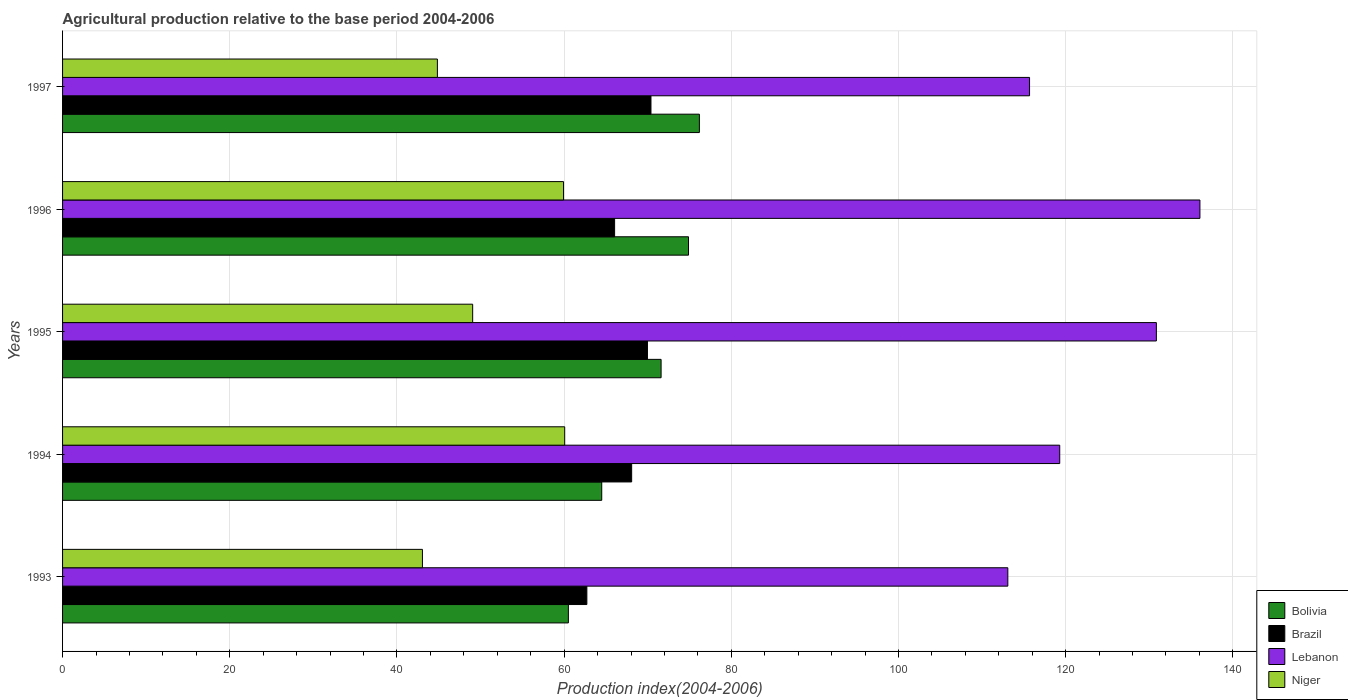How many groups of bars are there?
Your answer should be very brief. 5. How many bars are there on the 3rd tick from the bottom?
Your answer should be compact. 4. What is the agricultural production index in Lebanon in 1996?
Ensure brevity in your answer.  136.06. Across all years, what is the maximum agricultural production index in Bolivia?
Your answer should be very brief. 76.18. Across all years, what is the minimum agricultural production index in Lebanon?
Your response must be concise. 113.08. In which year was the agricultural production index in Niger maximum?
Your response must be concise. 1994. In which year was the agricultural production index in Bolivia minimum?
Keep it short and to the point. 1993. What is the total agricultural production index in Lebanon in the graph?
Make the answer very short. 614.96. What is the difference between the agricultural production index in Niger in 1995 and that in 1997?
Provide a succinct answer. 4.22. What is the difference between the agricultural production index in Lebanon in 1994 and the agricultural production index in Brazil in 1997?
Keep it short and to the point. 48.9. What is the average agricultural production index in Lebanon per year?
Your response must be concise. 122.99. In the year 1996, what is the difference between the agricultural production index in Lebanon and agricultural production index in Niger?
Your answer should be very brief. 76.13. In how many years, is the agricultural production index in Lebanon greater than 76 ?
Keep it short and to the point. 5. What is the ratio of the agricultural production index in Lebanon in 1996 to that in 1997?
Your response must be concise. 1.18. What is the difference between the highest and the second highest agricultural production index in Lebanon?
Make the answer very short. 5.21. What is the difference between the highest and the lowest agricultural production index in Lebanon?
Your answer should be very brief. 22.98. Is the sum of the agricultural production index in Brazil in 1994 and 1995 greater than the maximum agricultural production index in Niger across all years?
Your response must be concise. Yes. What does the 4th bar from the top in 1995 represents?
Make the answer very short. Bolivia. What does the 3rd bar from the bottom in 1994 represents?
Ensure brevity in your answer.  Lebanon. Is it the case that in every year, the sum of the agricultural production index in Lebanon and agricultural production index in Bolivia is greater than the agricultural production index in Brazil?
Provide a succinct answer. Yes. How many bars are there?
Provide a succinct answer. 20. Are all the bars in the graph horizontal?
Your answer should be compact. Yes. How many years are there in the graph?
Provide a short and direct response. 5. What is the difference between two consecutive major ticks on the X-axis?
Your answer should be very brief. 20. Does the graph contain any zero values?
Keep it short and to the point. No. Does the graph contain grids?
Keep it short and to the point. Yes. Where does the legend appear in the graph?
Provide a short and direct response. Bottom right. How many legend labels are there?
Give a very brief answer. 4. How are the legend labels stacked?
Your response must be concise. Vertical. What is the title of the graph?
Provide a succinct answer. Agricultural production relative to the base period 2004-2006. Does "Samoa" appear as one of the legend labels in the graph?
Provide a short and direct response. No. What is the label or title of the X-axis?
Your answer should be very brief. Production index(2004-2006). What is the Production index(2004-2006) of Bolivia in 1993?
Make the answer very short. 60.51. What is the Production index(2004-2006) in Brazil in 1993?
Provide a short and direct response. 62.72. What is the Production index(2004-2006) in Lebanon in 1993?
Provide a short and direct response. 113.08. What is the Production index(2004-2006) of Niger in 1993?
Offer a terse response. 43.05. What is the Production index(2004-2006) in Bolivia in 1994?
Provide a succinct answer. 64.5. What is the Production index(2004-2006) of Brazil in 1994?
Offer a very short reply. 68.08. What is the Production index(2004-2006) in Lebanon in 1994?
Offer a terse response. 119.29. What is the Production index(2004-2006) of Niger in 1994?
Provide a succinct answer. 60.07. What is the Production index(2004-2006) in Bolivia in 1995?
Ensure brevity in your answer.  71.6. What is the Production index(2004-2006) in Brazil in 1995?
Make the answer very short. 69.97. What is the Production index(2004-2006) in Lebanon in 1995?
Make the answer very short. 130.85. What is the Production index(2004-2006) in Niger in 1995?
Provide a succinct answer. 49.06. What is the Production index(2004-2006) in Bolivia in 1996?
Offer a very short reply. 74.88. What is the Production index(2004-2006) in Brazil in 1996?
Offer a terse response. 66.04. What is the Production index(2004-2006) of Lebanon in 1996?
Provide a short and direct response. 136.06. What is the Production index(2004-2006) in Niger in 1996?
Offer a terse response. 59.93. What is the Production index(2004-2006) in Bolivia in 1997?
Offer a very short reply. 76.18. What is the Production index(2004-2006) of Brazil in 1997?
Your answer should be very brief. 70.39. What is the Production index(2004-2006) in Lebanon in 1997?
Provide a short and direct response. 115.68. What is the Production index(2004-2006) of Niger in 1997?
Provide a succinct answer. 44.84. Across all years, what is the maximum Production index(2004-2006) in Bolivia?
Provide a succinct answer. 76.18. Across all years, what is the maximum Production index(2004-2006) of Brazil?
Your answer should be very brief. 70.39. Across all years, what is the maximum Production index(2004-2006) of Lebanon?
Make the answer very short. 136.06. Across all years, what is the maximum Production index(2004-2006) in Niger?
Your answer should be compact. 60.07. Across all years, what is the minimum Production index(2004-2006) in Bolivia?
Keep it short and to the point. 60.51. Across all years, what is the minimum Production index(2004-2006) in Brazil?
Your answer should be compact. 62.72. Across all years, what is the minimum Production index(2004-2006) of Lebanon?
Your response must be concise. 113.08. Across all years, what is the minimum Production index(2004-2006) of Niger?
Give a very brief answer. 43.05. What is the total Production index(2004-2006) in Bolivia in the graph?
Your answer should be compact. 347.67. What is the total Production index(2004-2006) in Brazil in the graph?
Your answer should be very brief. 337.2. What is the total Production index(2004-2006) in Lebanon in the graph?
Your answer should be very brief. 614.96. What is the total Production index(2004-2006) in Niger in the graph?
Your response must be concise. 256.95. What is the difference between the Production index(2004-2006) in Bolivia in 1993 and that in 1994?
Provide a succinct answer. -3.99. What is the difference between the Production index(2004-2006) of Brazil in 1993 and that in 1994?
Ensure brevity in your answer.  -5.36. What is the difference between the Production index(2004-2006) in Lebanon in 1993 and that in 1994?
Give a very brief answer. -6.21. What is the difference between the Production index(2004-2006) in Niger in 1993 and that in 1994?
Give a very brief answer. -17.02. What is the difference between the Production index(2004-2006) in Bolivia in 1993 and that in 1995?
Your answer should be compact. -11.09. What is the difference between the Production index(2004-2006) in Brazil in 1993 and that in 1995?
Make the answer very short. -7.25. What is the difference between the Production index(2004-2006) in Lebanon in 1993 and that in 1995?
Your response must be concise. -17.77. What is the difference between the Production index(2004-2006) of Niger in 1993 and that in 1995?
Keep it short and to the point. -6.01. What is the difference between the Production index(2004-2006) of Bolivia in 1993 and that in 1996?
Your answer should be very brief. -14.37. What is the difference between the Production index(2004-2006) of Brazil in 1993 and that in 1996?
Your answer should be very brief. -3.32. What is the difference between the Production index(2004-2006) in Lebanon in 1993 and that in 1996?
Keep it short and to the point. -22.98. What is the difference between the Production index(2004-2006) in Niger in 1993 and that in 1996?
Offer a very short reply. -16.88. What is the difference between the Production index(2004-2006) in Bolivia in 1993 and that in 1997?
Provide a succinct answer. -15.67. What is the difference between the Production index(2004-2006) in Brazil in 1993 and that in 1997?
Offer a terse response. -7.67. What is the difference between the Production index(2004-2006) of Niger in 1993 and that in 1997?
Your answer should be very brief. -1.79. What is the difference between the Production index(2004-2006) of Bolivia in 1994 and that in 1995?
Keep it short and to the point. -7.1. What is the difference between the Production index(2004-2006) in Brazil in 1994 and that in 1995?
Your answer should be very brief. -1.89. What is the difference between the Production index(2004-2006) of Lebanon in 1994 and that in 1995?
Your answer should be compact. -11.56. What is the difference between the Production index(2004-2006) in Niger in 1994 and that in 1995?
Ensure brevity in your answer.  11.01. What is the difference between the Production index(2004-2006) of Bolivia in 1994 and that in 1996?
Your response must be concise. -10.38. What is the difference between the Production index(2004-2006) of Brazil in 1994 and that in 1996?
Your answer should be very brief. 2.04. What is the difference between the Production index(2004-2006) of Lebanon in 1994 and that in 1996?
Make the answer very short. -16.77. What is the difference between the Production index(2004-2006) of Niger in 1994 and that in 1996?
Ensure brevity in your answer.  0.14. What is the difference between the Production index(2004-2006) of Bolivia in 1994 and that in 1997?
Offer a terse response. -11.68. What is the difference between the Production index(2004-2006) of Brazil in 1994 and that in 1997?
Provide a succinct answer. -2.31. What is the difference between the Production index(2004-2006) of Lebanon in 1994 and that in 1997?
Give a very brief answer. 3.61. What is the difference between the Production index(2004-2006) in Niger in 1994 and that in 1997?
Ensure brevity in your answer.  15.23. What is the difference between the Production index(2004-2006) of Bolivia in 1995 and that in 1996?
Offer a terse response. -3.28. What is the difference between the Production index(2004-2006) of Brazil in 1995 and that in 1996?
Your answer should be very brief. 3.93. What is the difference between the Production index(2004-2006) of Lebanon in 1995 and that in 1996?
Ensure brevity in your answer.  -5.21. What is the difference between the Production index(2004-2006) in Niger in 1995 and that in 1996?
Your response must be concise. -10.87. What is the difference between the Production index(2004-2006) of Bolivia in 1995 and that in 1997?
Your answer should be compact. -4.58. What is the difference between the Production index(2004-2006) of Brazil in 1995 and that in 1997?
Your answer should be very brief. -0.42. What is the difference between the Production index(2004-2006) of Lebanon in 1995 and that in 1997?
Ensure brevity in your answer.  15.17. What is the difference between the Production index(2004-2006) in Niger in 1995 and that in 1997?
Give a very brief answer. 4.22. What is the difference between the Production index(2004-2006) of Bolivia in 1996 and that in 1997?
Offer a very short reply. -1.3. What is the difference between the Production index(2004-2006) in Brazil in 1996 and that in 1997?
Your response must be concise. -4.35. What is the difference between the Production index(2004-2006) in Lebanon in 1996 and that in 1997?
Offer a very short reply. 20.38. What is the difference between the Production index(2004-2006) of Niger in 1996 and that in 1997?
Your response must be concise. 15.09. What is the difference between the Production index(2004-2006) in Bolivia in 1993 and the Production index(2004-2006) in Brazil in 1994?
Ensure brevity in your answer.  -7.57. What is the difference between the Production index(2004-2006) of Bolivia in 1993 and the Production index(2004-2006) of Lebanon in 1994?
Your response must be concise. -58.78. What is the difference between the Production index(2004-2006) in Bolivia in 1993 and the Production index(2004-2006) in Niger in 1994?
Provide a succinct answer. 0.44. What is the difference between the Production index(2004-2006) of Brazil in 1993 and the Production index(2004-2006) of Lebanon in 1994?
Provide a short and direct response. -56.57. What is the difference between the Production index(2004-2006) in Brazil in 1993 and the Production index(2004-2006) in Niger in 1994?
Your response must be concise. 2.65. What is the difference between the Production index(2004-2006) of Lebanon in 1993 and the Production index(2004-2006) of Niger in 1994?
Offer a very short reply. 53.01. What is the difference between the Production index(2004-2006) in Bolivia in 1993 and the Production index(2004-2006) in Brazil in 1995?
Keep it short and to the point. -9.46. What is the difference between the Production index(2004-2006) in Bolivia in 1993 and the Production index(2004-2006) in Lebanon in 1995?
Keep it short and to the point. -70.34. What is the difference between the Production index(2004-2006) of Bolivia in 1993 and the Production index(2004-2006) of Niger in 1995?
Your answer should be very brief. 11.45. What is the difference between the Production index(2004-2006) in Brazil in 1993 and the Production index(2004-2006) in Lebanon in 1995?
Ensure brevity in your answer.  -68.13. What is the difference between the Production index(2004-2006) of Brazil in 1993 and the Production index(2004-2006) of Niger in 1995?
Your answer should be compact. 13.66. What is the difference between the Production index(2004-2006) of Lebanon in 1993 and the Production index(2004-2006) of Niger in 1995?
Give a very brief answer. 64.02. What is the difference between the Production index(2004-2006) of Bolivia in 1993 and the Production index(2004-2006) of Brazil in 1996?
Make the answer very short. -5.53. What is the difference between the Production index(2004-2006) of Bolivia in 1993 and the Production index(2004-2006) of Lebanon in 1996?
Keep it short and to the point. -75.55. What is the difference between the Production index(2004-2006) in Bolivia in 1993 and the Production index(2004-2006) in Niger in 1996?
Make the answer very short. 0.58. What is the difference between the Production index(2004-2006) in Brazil in 1993 and the Production index(2004-2006) in Lebanon in 1996?
Keep it short and to the point. -73.34. What is the difference between the Production index(2004-2006) of Brazil in 1993 and the Production index(2004-2006) of Niger in 1996?
Your response must be concise. 2.79. What is the difference between the Production index(2004-2006) of Lebanon in 1993 and the Production index(2004-2006) of Niger in 1996?
Your answer should be compact. 53.15. What is the difference between the Production index(2004-2006) in Bolivia in 1993 and the Production index(2004-2006) in Brazil in 1997?
Your response must be concise. -9.88. What is the difference between the Production index(2004-2006) of Bolivia in 1993 and the Production index(2004-2006) of Lebanon in 1997?
Your response must be concise. -55.17. What is the difference between the Production index(2004-2006) in Bolivia in 1993 and the Production index(2004-2006) in Niger in 1997?
Give a very brief answer. 15.67. What is the difference between the Production index(2004-2006) in Brazil in 1993 and the Production index(2004-2006) in Lebanon in 1997?
Provide a succinct answer. -52.96. What is the difference between the Production index(2004-2006) of Brazil in 1993 and the Production index(2004-2006) of Niger in 1997?
Your response must be concise. 17.88. What is the difference between the Production index(2004-2006) in Lebanon in 1993 and the Production index(2004-2006) in Niger in 1997?
Offer a terse response. 68.24. What is the difference between the Production index(2004-2006) of Bolivia in 1994 and the Production index(2004-2006) of Brazil in 1995?
Offer a very short reply. -5.47. What is the difference between the Production index(2004-2006) of Bolivia in 1994 and the Production index(2004-2006) of Lebanon in 1995?
Provide a short and direct response. -66.35. What is the difference between the Production index(2004-2006) in Bolivia in 1994 and the Production index(2004-2006) in Niger in 1995?
Your answer should be compact. 15.44. What is the difference between the Production index(2004-2006) of Brazil in 1994 and the Production index(2004-2006) of Lebanon in 1995?
Provide a succinct answer. -62.77. What is the difference between the Production index(2004-2006) in Brazil in 1994 and the Production index(2004-2006) in Niger in 1995?
Make the answer very short. 19.02. What is the difference between the Production index(2004-2006) in Lebanon in 1994 and the Production index(2004-2006) in Niger in 1995?
Provide a succinct answer. 70.23. What is the difference between the Production index(2004-2006) of Bolivia in 1994 and the Production index(2004-2006) of Brazil in 1996?
Your answer should be very brief. -1.54. What is the difference between the Production index(2004-2006) in Bolivia in 1994 and the Production index(2004-2006) in Lebanon in 1996?
Your answer should be compact. -71.56. What is the difference between the Production index(2004-2006) of Bolivia in 1994 and the Production index(2004-2006) of Niger in 1996?
Give a very brief answer. 4.57. What is the difference between the Production index(2004-2006) of Brazil in 1994 and the Production index(2004-2006) of Lebanon in 1996?
Your answer should be compact. -67.98. What is the difference between the Production index(2004-2006) of Brazil in 1994 and the Production index(2004-2006) of Niger in 1996?
Provide a succinct answer. 8.15. What is the difference between the Production index(2004-2006) of Lebanon in 1994 and the Production index(2004-2006) of Niger in 1996?
Make the answer very short. 59.36. What is the difference between the Production index(2004-2006) of Bolivia in 1994 and the Production index(2004-2006) of Brazil in 1997?
Your answer should be compact. -5.89. What is the difference between the Production index(2004-2006) of Bolivia in 1994 and the Production index(2004-2006) of Lebanon in 1997?
Ensure brevity in your answer.  -51.18. What is the difference between the Production index(2004-2006) in Bolivia in 1994 and the Production index(2004-2006) in Niger in 1997?
Your response must be concise. 19.66. What is the difference between the Production index(2004-2006) of Brazil in 1994 and the Production index(2004-2006) of Lebanon in 1997?
Ensure brevity in your answer.  -47.6. What is the difference between the Production index(2004-2006) in Brazil in 1994 and the Production index(2004-2006) in Niger in 1997?
Give a very brief answer. 23.24. What is the difference between the Production index(2004-2006) of Lebanon in 1994 and the Production index(2004-2006) of Niger in 1997?
Your answer should be very brief. 74.45. What is the difference between the Production index(2004-2006) in Bolivia in 1995 and the Production index(2004-2006) in Brazil in 1996?
Give a very brief answer. 5.56. What is the difference between the Production index(2004-2006) in Bolivia in 1995 and the Production index(2004-2006) in Lebanon in 1996?
Provide a short and direct response. -64.46. What is the difference between the Production index(2004-2006) of Bolivia in 1995 and the Production index(2004-2006) of Niger in 1996?
Provide a short and direct response. 11.67. What is the difference between the Production index(2004-2006) in Brazil in 1995 and the Production index(2004-2006) in Lebanon in 1996?
Keep it short and to the point. -66.09. What is the difference between the Production index(2004-2006) of Brazil in 1995 and the Production index(2004-2006) of Niger in 1996?
Your response must be concise. 10.04. What is the difference between the Production index(2004-2006) in Lebanon in 1995 and the Production index(2004-2006) in Niger in 1996?
Offer a very short reply. 70.92. What is the difference between the Production index(2004-2006) of Bolivia in 1995 and the Production index(2004-2006) of Brazil in 1997?
Make the answer very short. 1.21. What is the difference between the Production index(2004-2006) of Bolivia in 1995 and the Production index(2004-2006) of Lebanon in 1997?
Ensure brevity in your answer.  -44.08. What is the difference between the Production index(2004-2006) in Bolivia in 1995 and the Production index(2004-2006) in Niger in 1997?
Offer a terse response. 26.76. What is the difference between the Production index(2004-2006) of Brazil in 1995 and the Production index(2004-2006) of Lebanon in 1997?
Provide a succinct answer. -45.71. What is the difference between the Production index(2004-2006) in Brazil in 1995 and the Production index(2004-2006) in Niger in 1997?
Make the answer very short. 25.13. What is the difference between the Production index(2004-2006) of Lebanon in 1995 and the Production index(2004-2006) of Niger in 1997?
Provide a succinct answer. 86.01. What is the difference between the Production index(2004-2006) of Bolivia in 1996 and the Production index(2004-2006) of Brazil in 1997?
Ensure brevity in your answer.  4.49. What is the difference between the Production index(2004-2006) of Bolivia in 1996 and the Production index(2004-2006) of Lebanon in 1997?
Provide a short and direct response. -40.8. What is the difference between the Production index(2004-2006) of Bolivia in 1996 and the Production index(2004-2006) of Niger in 1997?
Make the answer very short. 30.04. What is the difference between the Production index(2004-2006) of Brazil in 1996 and the Production index(2004-2006) of Lebanon in 1997?
Make the answer very short. -49.64. What is the difference between the Production index(2004-2006) of Brazil in 1996 and the Production index(2004-2006) of Niger in 1997?
Make the answer very short. 21.2. What is the difference between the Production index(2004-2006) of Lebanon in 1996 and the Production index(2004-2006) of Niger in 1997?
Your response must be concise. 91.22. What is the average Production index(2004-2006) in Bolivia per year?
Keep it short and to the point. 69.53. What is the average Production index(2004-2006) of Brazil per year?
Ensure brevity in your answer.  67.44. What is the average Production index(2004-2006) of Lebanon per year?
Offer a very short reply. 122.99. What is the average Production index(2004-2006) in Niger per year?
Your answer should be compact. 51.39. In the year 1993, what is the difference between the Production index(2004-2006) of Bolivia and Production index(2004-2006) of Brazil?
Your answer should be very brief. -2.21. In the year 1993, what is the difference between the Production index(2004-2006) in Bolivia and Production index(2004-2006) in Lebanon?
Ensure brevity in your answer.  -52.57. In the year 1993, what is the difference between the Production index(2004-2006) of Bolivia and Production index(2004-2006) of Niger?
Your response must be concise. 17.46. In the year 1993, what is the difference between the Production index(2004-2006) in Brazil and Production index(2004-2006) in Lebanon?
Ensure brevity in your answer.  -50.36. In the year 1993, what is the difference between the Production index(2004-2006) of Brazil and Production index(2004-2006) of Niger?
Offer a very short reply. 19.67. In the year 1993, what is the difference between the Production index(2004-2006) in Lebanon and Production index(2004-2006) in Niger?
Keep it short and to the point. 70.03. In the year 1994, what is the difference between the Production index(2004-2006) of Bolivia and Production index(2004-2006) of Brazil?
Your answer should be compact. -3.58. In the year 1994, what is the difference between the Production index(2004-2006) in Bolivia and Production index(2004-2006) in Lebanon?
Your answer should be very brief. -54.79. In the year 1994, what is the difference between the Production index(2004-2006) in Bolivia and Production index(2004-2006) in Niger?
Give a very brief answer. 4.43. In the year 1994, what is the difference between the Production index(2004-2006) of Brazil and Production index(2004-2006) of Lebanon?
Your answer should be compact. -51.21. In the year 1994, what is the difference between the Production index(2004-2006) in Brazil and Production index(2004-2006) in Niger?
Your response must be concise. 8.01. In the year 1994, what is the difference between the Production index(2004-2006) in Lebanon and Production index(2004-2006) in Niger?
Provide a short and direct response. 59.22. In the year 1995, what is the difference between the Production index(2004-2006) of Bolivia and Production index(2004-2006) of Brazil?
Keep it short and to the point. 1.63. In the year 1995, what is the difference between the Production index(2004-2006) of Bolivia and Production index(2004-2006) of Lebanon?
Provide a succinct answer. -59.25. In the year 1995, what is the difference between the Production index(2004-2006) in Bolivia and Production index(2004-2006) in Niger?
Give a very brief answer. 22.54. In the year 1995, what is the difference between the Production index(2004-2006) in Brazil and Production index(2004-2006) in Lebanon?
Keep it short and to the point. -60.88. In the year 1995, what is the difference between the Production index(2004-2006) of Brazil and Production index(2004-2006) of Niger?
Your answer should be compact. 20.91. In the year 1995, what is the difference between the Production index(2004-2006) of Lebanon and Production index(2004-2006) of Niger?
Your answer should be compact. 81.79. In the year 1996, what is the difference between the Production index(2004-2006) in Bolivia and Production index(2004-2006) in Brazil?
Your answer should be very brief. 8.84. In the year 1996, what is the difference between the Production index(2004-2006) of Bolivia and Production index(2004-2006) of Lebanon?
Your response must be concise. -61.18. In the year 1996, what is the difference between the Production index(2004-2006) in Bolivia and Production index(2004-2006) in Niger?
Offer a terse response. 14.95. In the year 1996, what is the difference between the Production index(2004-2006) in Brazil and Production index(2004-2006) in Lebanon?
Provide a short and direct response. -70.02. In the year 1996, what is the difference between the Production index(2004-2006) in Brazil and Production index(2004-2006) in Niger?
Ensure brevity in your answer.  6.11. In the year 1996, what is the difference between the Production index(2004-2006) of Lebanon and Production index(2004-2006) of Niger?
Make the answer very short. 76.13. In the year 1997, what is the difference between the Production index(2004-2006) in Bolivia and Production index(2004-2006) in Brazil?
Your response must be concise. 5.79. In the year 1997, what is the difference between the Production index(2004-2006) of Bolivia and Production index(2004-2006) of Lebanon?
Provide a short and direct response. -39.5. In the year 1997, what is the difference between the Production index(2004-2006) of Bolivia and Production index(2004-2006) of Niger?
Offer a very short reply. 31.34. In the year 1997, what is the difference between the Production index(2004-2006) of Brazil and Production index(2004-2006) of Lebanon?
Your answer should be compact. -45.29. In the year 1997, what is the difference between the Production index(2004-2006) of Brazil and Production index(2004-2006) of Niger?
Provide a succinct answer. 25.55. In the year 1997, what is the difference between the Production index(2004-2006) in Lebanon and Production index(2004-2006) in Niger?
Your answer should be compact. 70.84. What is the ratio of the Production index(2004-2006) of Bolivia in 1993 to that in 1994?
Offer a very short reply. 0.94. What is the ratio of the Production index(2004-2006) of Brazil in 1993 to that in 1994?
Your answer should be compact. 0.92. What is the ratio of the Production index(2004-2006) in Lebanon in 1993 to that in 1994?
Keep it short and to the point. 0.95. What is the ratio of the Production index(2004-2006) of Niger in 1993 to that in 1994?
Your answer should be compact. 0.72. What is the ratio of the Production index(2004-2006) of Bolivia in 1993 to that in 1995?
Offer a terse response. 0.85. What is the ratio of the Production index(2004-2006) of Brazil in 1993 to that in 1995?
Your answer should be very brief. 0.9. What is the ratio of the Production index(2004-2006) of Lebanon in 1993 to that in 1995?
Make the answer very short. 0.86. What is the ratio of the Production index(2004-2006) in Niger in 1993 to that in 1995?
Make the answer very short. 0.88. What is the ratio of the Production index(2004-2006) in Bolivia in 1993 to that in 1996?
Your answer should be compact. 0.81. What is the ratio of the Production index(2004-2006) of Brazil in 1993 to that in 1996?
Your answer should be compact. 0.95. What is the ratio of the Production index(2004-2006) of Lebanon in 1993 to that in 1996?
Give a very brief answer. 0.83. What is the ratio of the Production index(2004-2006) of Niger in 1993 to that in 1996?
Offer a terse response. 0.72. What is the ratio of the Production index(2004-2006) of Bolivia in 1993 to that in 1997?
Ensure brevity in your answer.  0.79. What is the ratio of the Production index(2004-2006) in Brazil in 1993 to that in 1997?
Offer a terse response. 0.89. What is the ratio of the Production index(2004-2006) in Lebanon in 1993 to that in 1997?
Offer a very short reply. 0.98. What is the ratio of the Production index(2004-2006) in Niger in 1993 to that in 1997?
Your answer should be very brief. 0.96. What is the ratio of the Production index(2004-2006) of Bolivia in 1994 to that in 1995?
Give a very brief answer. 0.9. What is the ratio of the Production index(2004-2006) of Lebanon in 1994 to that in 1995?
Your response must be concise. 0.91. What is the ratio of the Production index(2004-2006) of Niger in 1994 to that in 1995?
Your answer should be compact. 1.22. What is the ratio of the Production index(2004-2006) in Bolivia in 1994 to that in 1996?
Your answer should be very brief. 0.86. What is the ratio of the Production index(2004-2006) in Brazil in 1994 to that in 1996?
Ensure brevity in your answer.  1.03. What is the ratio of the Production index(2004-2006) in Lebanon in 1994 to that in 1996?
Your answer should be compact. 0.88. What is the ratio of the Production index(2004-2006) in Niger in 1994 to that in 1996?
Your answer should be compact. 1. What is the ratio of the Production index(2004-2006) in Bolivia in 1994 to that in 1997?
Make the answer very short. 0.85. What is the ratio of the Production index(2004-2006) of Brazil in 1994 to that in 1997?
Provide a short and direct response. 0.97. What is the ratio of the Production index(2004-2006) of Lebanon in 1994 to that in 1997?
Offer a very short reply. 1.03. What is the ratio of the Production index(2004-2006) of Niger in 1994 to that in 1997?
Your answer should be compact. 1.34. What is the ratio of the Production index(2004-2006) of Bolivia in 1995 to that in 1996?
Your answer should be compact. 0.96. What is the ratio of the Production index(2004-2006) in Brazil in 1995 to that in 1996?
Offer a very short reply. 1.06. What is the ratio of the Production index(2004-2006) of Lebanon in 1995 to that in 1996?
Offer a terse response. 0.96. What is the ratio of the Production index(2004-2006) of Niger in 1995 to that in 1996?
Make the answer very short. 0.82. What is the ratio of the Production index(2004-2006) of Bolivia in 1995 to that in 1997?
Your answer should be compact. 0.94. What is the ratio of the Production index(2004-2006) in Lebanon in 1995 to that in 1997?
Your response must be concise. 1.13. What is the ratio of the Production index(2004-2006) in Niger in 1995 to that in 1997?
Ensure brevity in your answer.  1.09. What is the ratio of the Production index(2004-2006) in Bolivia in 1996 to that in 1997?
Offer a terse response. 0.98. What is the ratio of the Production index(2004-2006) in Brazil in 1996 to that in 1997?
Ensure brevity in your answer.  0.94. What is the ratio of the Production index(2004-2006) in Lebanon in 1996 to that in 1997?
Your response must be concise. 1.18. What is the ratio of the Production index(2004-2006) in Niger in 1996 to that in 1997?
Offer a terse response. 1.34. What is the difference between the highest and the second highest Production index(2004-2006) of Bolivia?
Make the answer very short. 1.3. What is the difference between the highest and the second highest Production index(2004-2006) of Brazil?
Offer a terse response. 0.42. What is the difference between the highest and the second highest Production index(2004-2006) of Lebanon?
Provide a short and direct response. 5.21. What is the difference between the highest and the second highest Production index(2004-2006) in Niger?
Make the answer very short. 0.14. What is the difference between the highest and the lowest Production index(2004-2006) in Bolivia?
Make the answer very short. 15.67. What is the difference between the highest and the lowest Production index(2004-2006) in Brazil?
Provide a succinct answer. 7.67. What is the difference between the highest and the lowest Production index(2004-2006) of Lebanon?
Provide a succinct answer. 22.98. What is the difference between the highest and the lowest Production index(2004-2006) of Niger?
Ensure brevity in your answer.  17.02. 